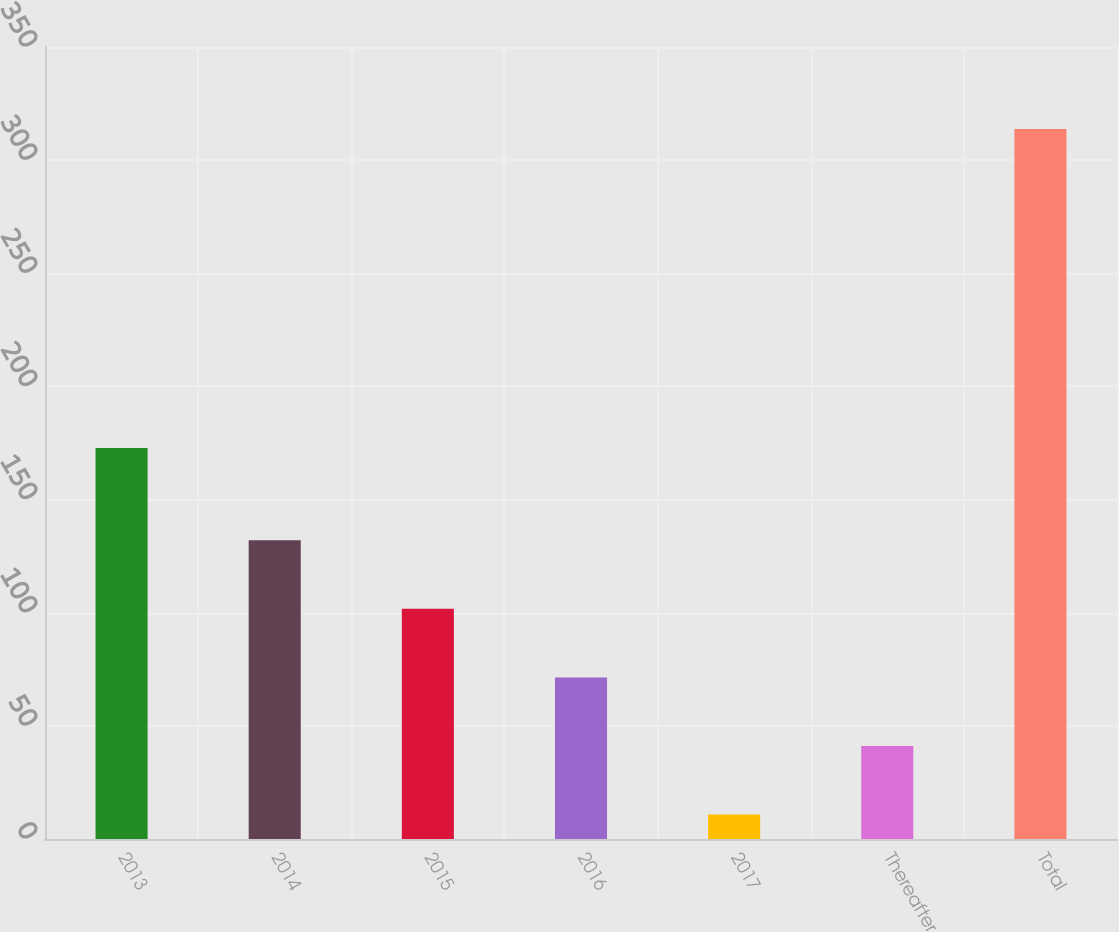<chart> <loc_0><loc_0><loc_500><loc_500><bar_chart><fcel>2013<fcel>2014<fcel>2015<fcel>2016<fcel>2017<fcel>Thereafter<fcel>Total<nl><fcel>172.8<fcel>132<fcel>101.7<fcel>71.4<fcel>10.8<fcel>41.1<fcel>313.8<nl></chart> 